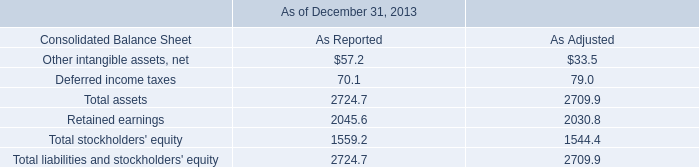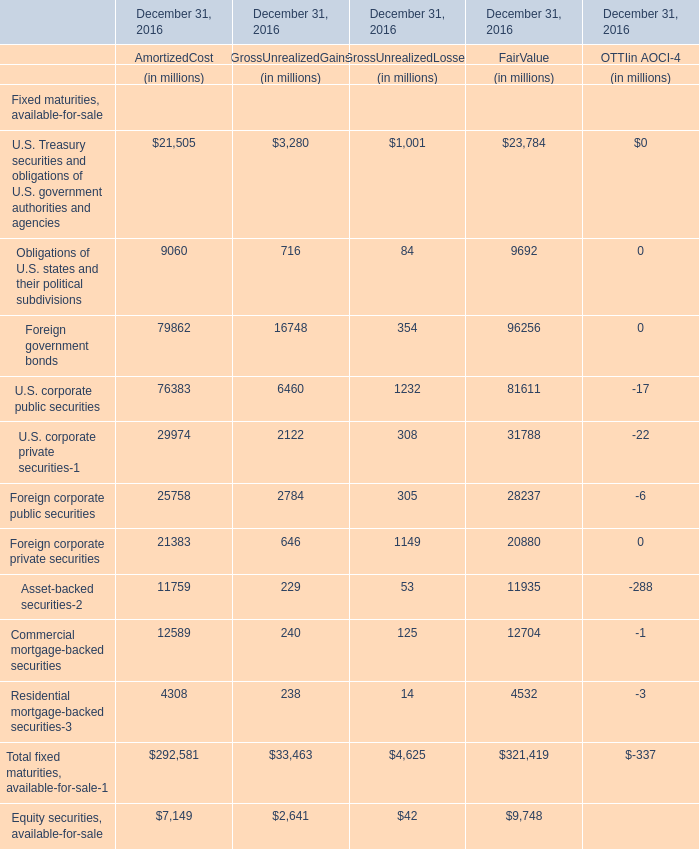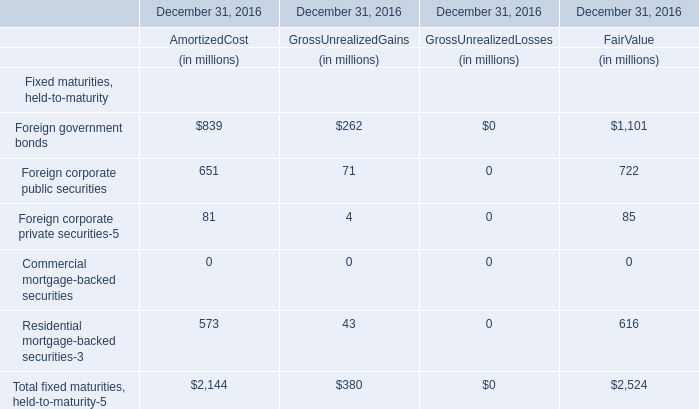What is the percentage of all Foreign corporate private securities-5 that are positive to the total amount, in 2016? 
Computations: ((81 + 4) / ((81 + 4) + 85))
Answer: 0.5. 